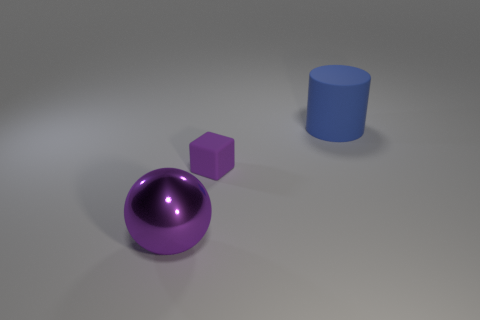How many other things are there of the same shape as the large purple metallic object?
Make the answer very short. 0. How many purple objects are metallic balls or large rubber cylinders?
Make the answer very short. 1. Do the big shiny object and the purple matte object have the same shape?
Offer a very short reply. No. Is there a blue rubber cylinder in front of the thing that is to the right of the small purple object?
Your answer should be very brief. No. Are there an equal number of blue cylinders that are in front of the big purple ball and large matte cylinders?
Offer a very short reply. No. What number of other objects are the same size as the purple metal sphere?
Your answer should be very brief. 1. Do the big thing that is left of the large rubber thing and the object behind the purple matte object have the same material?
Ensure brevity in your answer.  No. There is a purple object to the right of the big object in front of the cube; what is its size?
Offer a terse response. Small. Are there any tiny matte blocks of the same color as the metal ball?
Ensure brevity in your answer.  Yes. There is a big object that is on the left side of the large blue cylinder; is its color the same as the large thing that is behind the purple metal object?
Provide a short and direct response. No. 